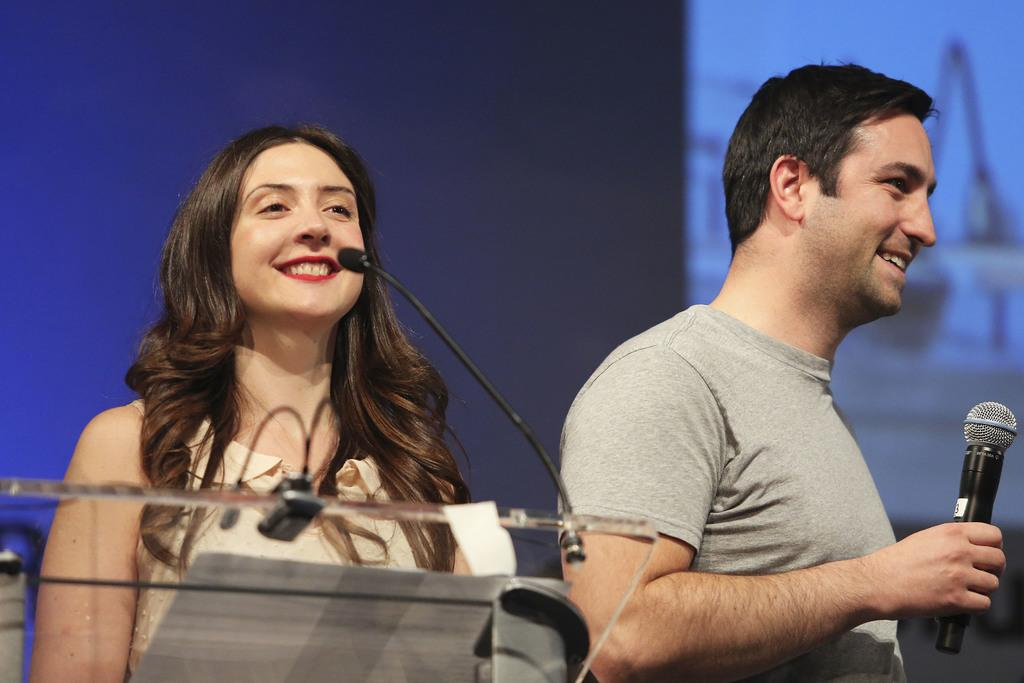How many people are in the image? There are two persons in the image. Can you describe the lady in the image? The lady is on the left side, and she is smiling. Can you describe the man in the image? The man is on the right side, and he is also smiling. He is holding a microphone. What type of glass is the man holding in the image? There is no glass present in the image; the man is holding a microphone. Can you tell me how many toes the lady has in the image? There is no information about the lady's toes in the image, as it only shows her from the waist up. 